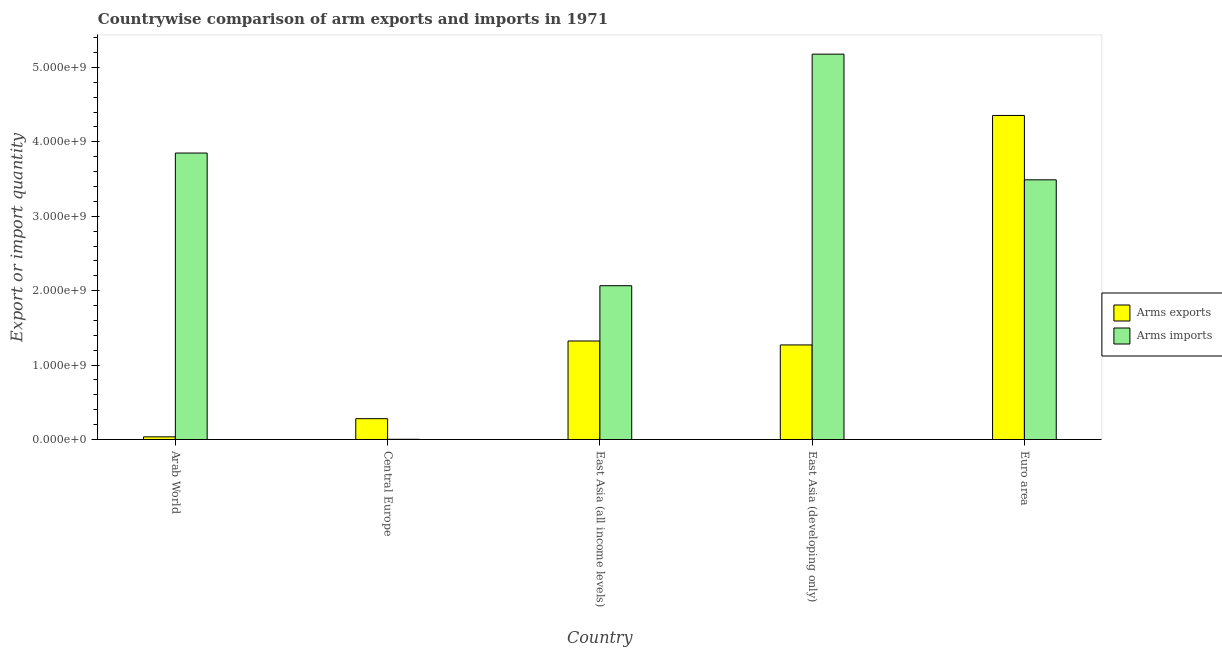How many groups of bars are there?
Make the answer very short. 5. Are the number of bars per tick equal to the number of legend labels?
Ensure brevity in your answer.  Yes. Are the number of bars on each tick of the X-axis equal?
Your answer should be compact. Yes. What is the label of the 1st group of bars from the left?
Keep it short and to the point. Arab World. In how many cases, is the number of bars for a given country not equal to the number of legend labels?
Ensure brevity in your answer.  0. What is the arms imports in East Asia (all income levels)?
Offer a very short reply. 2.07e+09. Across all countries, what is the maximum arms exports?
Give a very brief answer. 4.36e+09. Across all countries, what is the minimum arms imports?
Keep it short and to the point. 3.00e+06. In which country was the arms imports maximum?
Give a very brief answer. East Asia (developing only). In which country was the arms imports minimum?
Make the answer very short. Central Europe. What is the total arms exports in the graph?
Keep it short and to the point. 7.27e+09. What is the difference between the arms imports in Arab World and that in East Asia (all income levels)?
Offer a very short reply. 1.78e+09. What is the difference between the arms imports in East Asia (developing only) and the arms exports in East Asia (all income levels)?
Your response must be concise. 3.86e+09. What is the average arms imports per country?
Offer a terse response. 2.92e+09. What is the difference between the arms exports and arms imports in Arab World?
Make the answer very short. -3.81e+09. What is the ratio of the arms imports in Central Europe to that in East Asia (developing only)?
Ensure brevity in your answer.  0. What is the difference between the highest and the second highest arms imports?
Your answer should be compact. 1.33e+09. What is the difference between the highest and the lowest arms exports?
Ensure brevity in your answer.  4.32e+09. In how many countries, is the arms exports greater than the average arms exports taken over all countries?
Make the answer very short. 1. What does the 2nd bar from the left in East Asia (developing only) represents?
Your answer should be very brief. Arms imports. What does the 2nd bar from the right in East Asia (all income levels) represents?
Provide a succinct answer. Arms exports. What is the difference between two consecutive major ticks on the Y-axis?
Provide a short and direct response. 1.00e+09. Are the values on the major ticks of Y-axis written in scientific E-notation?
Provide a succinct answer. Yes. Does the graph contain grids?
Offer a very short reply. No. How many legend labels are there?
Your answer should be very brief. 2. What is the title of the graph?
Provide a succinct answer. Countrywise comparison of arm exports and imports in 1971. What is the label or title of the Y-axis?
Provide a short and direct response. Export or import quantity. What is the Export or import quantity of Arms exports in Arab World?
Provide a short and direct response. 3.60e+07. What is the Export or import quantity in Arms imports in Arab World?
Provide a succinct answer. 3.85e+09. What is the Export or import quantity of Arms exports in Central Europe?
Your response must be concise. 2.80e+08. What is the Export or import quantity in Arms imports in Central Europe?
Ensure brevity in your answer.  3.00e+06. What is the Export or import quantity in Arms exports in East Asia (all income levels)?
Your answer should be compact. 1.32e+09. What is the Export or import quantity in Arms imports in East Asia (all income levels)?
Provide a short and direct response. 2.07e+09. What is the Export or import quantity of Arms exports in East Asia (developing only)?
Provide a succinct answer. 1.27e+09. What is the Export or import quantity of Arms imports in East Asia (developing only)?
Offer a terse response. 5.18e+09. What is the Export or import quantity of Arms exports in Euro area?
Provide a succinct answer. 4.36e+09. What is the Export or import quantity in Arms imports in Euro area?
Provide a short and direct response. 3.49e+09. Across all countries, what is the maximum Export or import quantity of Arms exports?
Offer a very short reply. 4.36e+09. Across all countries, what is the maximum Export or import quantity in Arms imports?
Give a very brief answer. 5.18e+09. Across all countries, what is the minimum Export or import quantity of Arms exports?
Offer a terse response. 3.60e+07. Across all countries, what is the minimum Export or import quantity of Arms imports?
Your response must be concise. 3.00e+06. What is the total Export or import quantity of Arms exports in the graph?
Offer a terse response. 7.27e+09. What is the total Export or import quantity of Arms imports in the graph?
Keep it short and to the point. 1.46e+1. What is the difference between the Export or import quantity of Arms exports in Arab World and that in Central Europe?
Offer a terse response. -2.44e+08. What is the difference between the Export or import quantity in Arms imports in Arab World and that in Central Europe?
Provide a short and direct response. 3.85e+09. What is the difference between the Export or import quantity of Arms exports in Arab World and that in East Asia (all income levels)?
Keep it short and to the point. -1.29e+09. What is the difference between the Export or import quantity of Arms imports in Arab World and that in East Asia (all income levels)?
Provide a succinct answer. 1.78e+09. What is the difference between the Export or import quantity in Arms exports in Arab World and that in East Asia (developing only)?
Provide a succinct answer. -1.24e+09. What is the difference between the Export or import quantity of Arms imports in Arab World and that in East Asia (developing only)?
Provide a succinct answer. -1.33e+09. What is the difference between the Export or import quantity in Arms exports in Arab World and that in Euro area?
Offer a very short reply. -4.32e+09. What is the difference between the Export or import quantity in Arms imports in Arab World and that in Euro area?
Ensure brevity in your answer.  3.60e+08. What is the difference between the Export or import quantity of Arms exports in Central Europe and that in East Asia (all income levels)?
Give a very brief answer. -1.04e+09. What is the difference between the Export or import quantity of Arms imports in Central Europe and that in East Asia (all income levels)?
Offer a very short reply. -2.06e+09. What is the difference between the Export or import quantity in Arms exports in Central Europe and that in East Asia (developing only)?
Provide a succinct answer. -9.91e+08. What is the difference between the Export or import quantity of Arms imports in Central Europe and that in East Asia (developing only)?
Ensure brevity in your answer.  -5.18e+09. What is the difference between the Export or import quantity in Arms exports in Central Europe and that in Euro area?
Keep it short and to the point. -4.08e+09. What is the difference between the Export or import quantity of Arms imports in Central Europe and that in Euro area?
Offer a terse response. -3.49e+09. What is the difference between the Export or import quantity of Arms exports in East Asia (all income levels) and that in East Asia (developing only)?
Make the answer very short. 5.30e+07. What is the difference between the Export or import quantity in Arms imports in East Asia (all income levels) and that in East Asia (developing only)?
Offer a terse response. -3.11e+09. What is the difference between the Export or import quantity in Arms exports in East Asia (all income levels) and that in Euro area?
Offer a terse response. -3.03e+09. What is the difference between the Export or import quantity in Arms imports in East Asia (all income levels) and that in Euro area?
Offer a very short reply. -1.42e+09. What is the difference between the Export or import quantity of Arms exports in East Asia (developing only) and that in Euro area?
Keep it short and to the point. -3.08e+09. What is the difference between the Export or import quantity of Arms imports in East Asia (developing only) and that in Euro area?
Provide a succinct answer. 1.69e+09. What is the difference between the Export or import quantity in Arms exports in Arab World and the Export or import quantity in Arms imports in Central Europe?
Make the answer very short. 3.30e+07. What is the difference between the Export or import quantity in Arms exports in Arab World and the Export or import quantity in Arms imports in East Asia (all income levels)?
Give a very brief answer. -2.03e+09. What is the difference between the Export or import quantity of Arms exports in Arab World and the Export or import quantity of Arms imports in East Asia (developing only)?
Your answer should be very brief. -5.14e+09. What is the difference between the Export or import quantity of Arms exports in Arab World and the Export or import quantity of Arms imports in Euro area?
Provide a short and direct response. -3.45e+09. What is the difference between the Export or import quantity of Arms exports in Central Europe and the Export or import quantity of Arms imports in East Asia (all income levels)?
Your response must be concise. -1.79e+09. What is the difference between the Export or import quantity in Arms exports in Central Europe and the Export or import quantity in Arms imports in East Asia (developing only)?
Your response must be concise. -4.90e+09. What is the difference between the Export or import quantity in Arms exports in Central Europe and the Export or import quantity in Arms imports in Euro area?
Give a very brief answer. -3.21e+09. What is the difference between the Export or import quantity in Arms exports in East Asia (all income levels) and the Export or import quantity in Arms imports in East Asia (developing only)?
Keep it short and to the point. -3.86e+09. What is the difference between the Export or import quantity in Arms exports in East Asia (all income levels) and the Export or import quantity in Arms imports in Euro area?
Your answer should be very brief. -2.17e+09. What is the difference between the Export or import quantity in Arms exports in East Asia (developing only) and the Export or import quantity in Arms imports in Euro area?
Offer a terse response. -2.22e+09. What is the average Export or import quantity of Arms exports per country?
Give a very brief answer. 1.45e+09. What is the average Export or import quantity in Arms imports per country?
Provide a short and direct response. 2.92e+09. What is the difference between the Export or import quantity in Arms exports and Export or import quantity in Arms imports in Arab World?
Keep it short and to the point. -3.81e+09. What is the difference between the Export or import quantity of Arms exports and Export or import quantity of Arms imports in Central Europe?
Make the answer very short. 2.77e+08. What is the difference between the Export or import quantity of Arms exports and Export or import quantity of Arms imports in East Asia (all income levels)?
Your response must be concise. -7.43e+08. What is the difference between the Export or import quantity in Arms exports and Export or import quantity in Arms imports in East Asia (developing only)?
Your answer should be very brief. -3.91e+09. What is the difference between the Export or import quantity in Arms exports and Export or import quantity in Arms imports in Euro area?
Your answer should be very brief. 8.65e+08. What is the ratio of the Export or import quantity of Arms exports in Arab World to that in Central Europe?
Your response must be concise. 0.13. What is the ratio of the Export or import quantity in Arms imports in Arab World to that in Central Europe?
Give a very brief answer. 1283.33. What is the ratio of the Export or import quantity of Arms exports in Arab World to that in East Asia (all income levels)?
Provide a short and direct response. 0.03. What is the ratio of the Export or import quantity in Arms imports in Arab World to that in East Asia (all income levels)?
Make the answer very short. 1.86. What is the ratio of the Export or import quantity of Arms exports in Arab World to that in East Asia (developing only)?
Offer a terse response. 0.03. What is the ratio of the Export or import quantity in Arms imports in Arab World to that in East Asia (developing only)?
Give a very brief answer. 0.74. What is the ratio of the Export or import quantity of Arms exports in Arab World to that in Euro area?
Offer a terse response. 0.01. What is the ratio of the Export or import quantity in Arms imports in Arab World to that in Euro area?
Ensure brevity in your answer.  1.1. What is the ratio of the Export or import quantity in Arms exports in Central Europe to that in East Asia (all income levels)?
Your answer should be compact. 0.21. What is the ratio of the Export or import quantity in Arms imports in Central Europe to that in East Asia (all income levels)?
Keep it short and to the point. 0. What is the ratio of the Export or import quantity of Arms exports in Central Europe to that in East Asia (developing only)?
Make the answer very short. 0.22. What is the ratio of the Export or import quantity of Arms imports in Central Europe to that in East Asia (developing only)?
Offer a very short reply. 0. What is the ratio of the Export or import quantity in Arms exports in Central Europe to that in Euro area?
Provide a succinct answer. 0.06. What is the ratio of the Export or import quantity in Arms imports in Central Europe to that in Euro area?
Provide a short and direct response. 0. What is the ratio of the Export or import quantity of Arms exports in East Asia (all income levels) to that in East Asia (developing only)?
Your answer should be very brief. 1.04. What is the ratio of the Export or import quantity in Arms imports in East Asia (all income levels) to that in East Asia (developing only)?
Your answer should be compact. 0.4. What is the ratio of the Export or import quantity in Arms exports in East Asia (all income levels) to that in Euro area?
Provide a short and direct response. 0.3. What is the ratio of the Export or import quantity in Arms imports in East Asia (all income levels) to that in Euro area?
Provide a succinct answer. 0.59. What is the ratio of the Export or import quantity of Arms exports in East Asia (developing only) to that in Euro area?
Offer a terse response. 0.29. What is the ratio of the Export or import quantity of Arms imports in East Asia (developing only) to that in Euro area?
Make the answer very short. 1.48. What is the difference between the highest and the second highest Export or import quantity in Arms exports?
Offer a very short reply. 3.03e+09. What is the difference between the highest and the second highest Export or import quantity of Arms imports?
Give a very brief answer. 1.33e+09. What is the difference between the highest and the lowest Export or import quantity of Arms exports?
Your answer should be very brief. 4.32e+09. What is the difference between the highest and the lowest Export or import quantity in Arms imports?
Make the answer very short. 5.18e+09. 